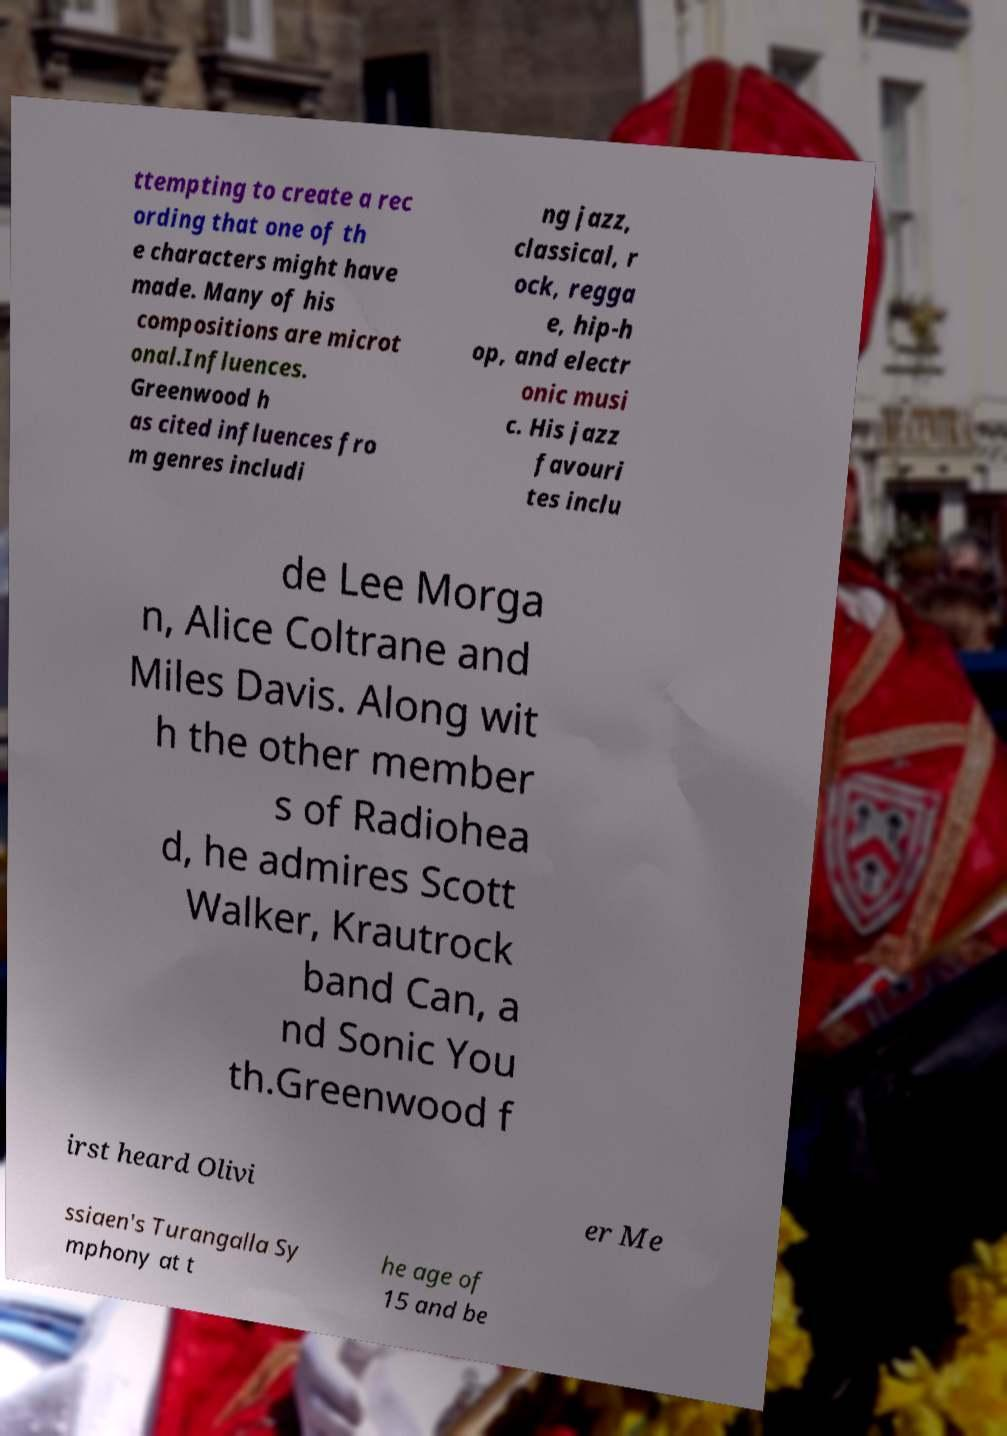Please read and relay the text visible in this image. What does it say? ttempting to create a rec ording that one of th e characters might have made. Many of his compositions are microt onal.Influences. Greenwood h as cited influences fro m genres includi ng jazz, classical, r ock, regga e, hip-h op, and electr onic musi c. His jazz favouri tes inclu de Lee Morga n, Alice Coltrane and Miles Davis. Along wit h the other member s of Radiohea d, he admires Scott Walker, Krautrock band Can, a nd Sonic You th.Greenwood f irst heard Olivi er Me ssiaen's Turangalla Sy mphony at t he age of 15 and be 